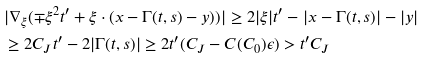<formula> <loc_0><loc_0><loc_500><loc_500>& | \nabla _ { \xi } ( \mp \xi ^ { 2 } t ^ { \prime } + \xi \cdot ( x - \Gamma ( t , s ) - y ) ) | \geq 2 | \xi | t ^ { \prime } - | x - \Gamma ( t , s ) | - | y | \\ & \geq 2 C _ { J } t ^ { \prime } - 2 | \Gamma ( t , s ) | \geq 2 t ^ { \prime } ( C _ { J } - C ( C _ { 0 } ) \epsilon ) > t ^ { \prime } C _ { J }</formula> 